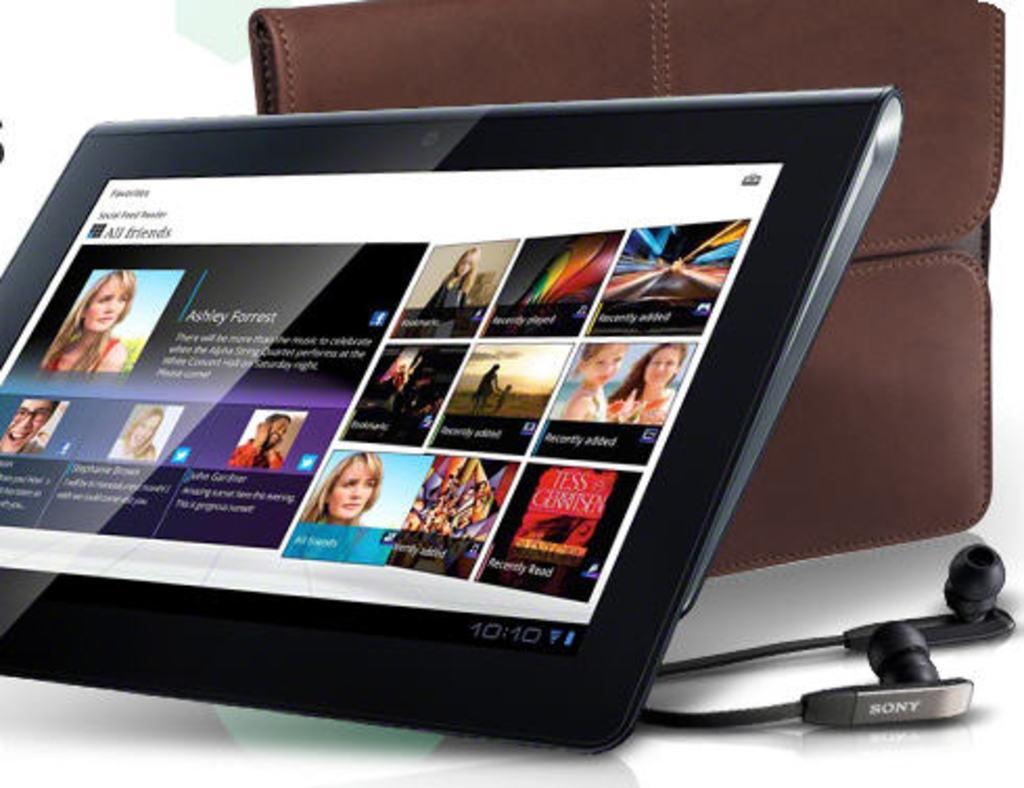Can you describe this image briefly? In this image there are some pictures and text on the tab. Beside the table there are headphones and a wallet on the table. 